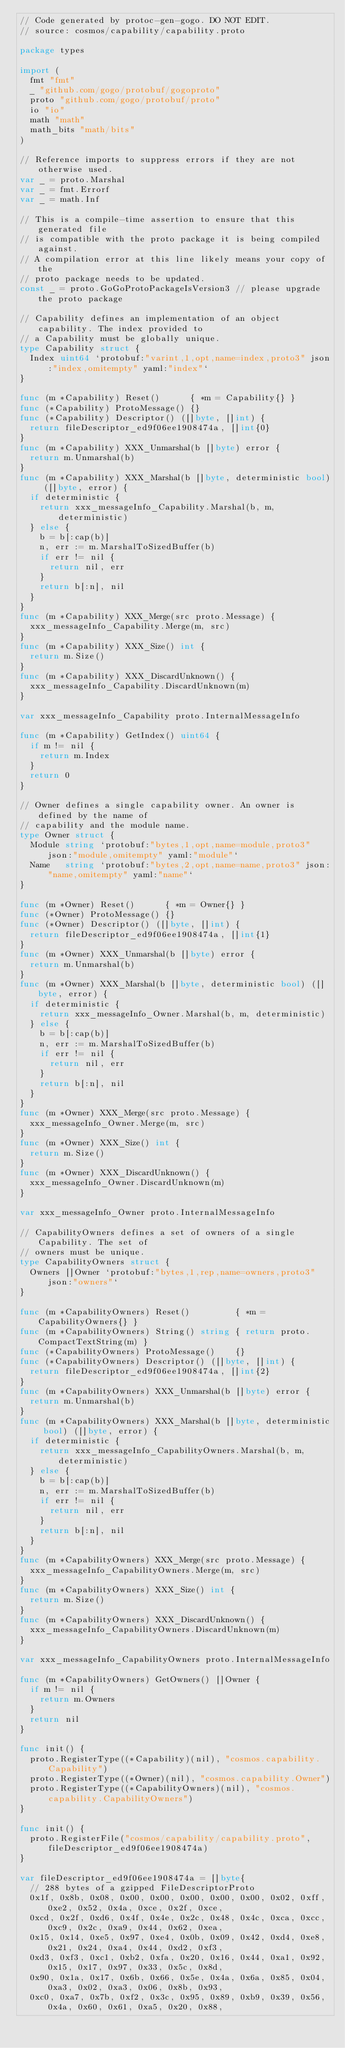<code> <loc_0><loc_0><loc_500><loc_500><_Go_>// Code generated by protoc-gen-gogo. DO NOT EDIT.
// source: cosmos/capability/capability.proto

package types

import (
	fmt "fmt"
	_ "github.com/gogo/protobuf/gogoproto"
	proto "github.com/gogo/protobuf/proto"
	io "io"
	math "math"
	math_bits "math/bits"
)

// Reference imports to suppress errors if they are not otherwise used.
var _ = proto.Marshal
var _ = fmt.Errorf
var _ = math.Inf

// This is a compile-time assertion to ensure that this generated file
// is compatible with the proto package it is being compiled against.
// A compilation error at this line likely means your copy of the
// proto package needs to be updated.
const _ = proto.GoGoProtoPackageIsVersion3 // please upgrade the proto package

// Capability defines an implementation of an object capability. The index provided to
// a Capability must be globally unique.
type Capability struct {
	Index uint64 `protobuf:"varint,1,opt,name=index,proto3" json:"index,omitempty" yaml:"index"`
}

func (m *Capability) Reset()      { *m = Capability{} }
func (*Capability) ProtoMessage() {}
func (*Capability) Descriptor() ([]byte, []int) {
	return fileDescriptor_ed9f06ee1908474a, []int{0}
}
func (m *Capability) XXX_Unmarshal(b []byte) error {
	return m.Unmarshal(b)
}
func (m *Capability) XXX_Marshal(b []byte, deterministic bool) ([]byte, error) {
	if deterministic {
		return xxx_messageInfo_Capability.Marshal(b, m, deterministic)
	} else {
		b = b[:cap(b)]
		n, err := m.MarshalToSizedBuffer(b)
		if err != nil {
			return nil, err
		}
		return b[:n], nil
	}
}
func (m *Capability) XXX_Merge(src proto.Message) {
	xxx_messageInfo_Capability.Merge(m, src)
}
func (m *Capability) XXX_Size() int {
	return m.Size()
}
func (m *Capability) XXX_DiscardUnknown() {
	xxx_messageInfo_Capability.DiscardUnknown(m)
}

var xxx_messageInfo_Capability proto.InternalMessageInfo

func (m *Capability) GetIndex() uint64 {
	if m != nil {
		return m.Index
	}
	return 0
}

// Owner defines a single capability owner. An owner is defined by the name of
// capability and the module name.
type Owner struct {
	Module string `protobuf:"bytes,1,opt,name=module,proto3" json:"module,omitempty" yaml:"module"`
	Name   string `protobuf:"bytes,2,opt,name=name,proto3" json:"name,omitempty" yaml:"name"`
}

func (m *Owner) Reset()      { *m = Owner{} }
func (*Owner) ProtoMessage() {}
func (*Owner) Descriptor() ([]byte, []int) {
	return fileDescriptor_ed9f06ee1908474a, []int{1}
}
func (m *Owner) XXX_Unmarshal(b []byte) error {
	return m.Unmarshal(b)
}
func (m *Owner) XXX_Marshal(b []byte, deterministic bool) ([]byte, error) {
	if deterministic {
		return xxx_messageInfo_Owner.Marshal(b, m, deterministic)
	} else {
		b = b[:cap(b)]
		n, err := m.MarshalToSizedBuffer(b)
		if err != nil {
			return nil, err
		}
		return b[:n], nil
	}
}
func (m *Owner) XXX_Merge(src proto.Message) {
	xxx_messageInfo_Owner.Merge(m, src)
}
func (m *Owner) XXX_Size() int {
	return m.Size()
}
func (m *Owner) XXX_DiscardUnknown() {
	xxx_messageInfo_Owner.DiscardUnknown(m)
}

var xxx_messageInfo_Owner proto.InternalMessageInfo

// CapabilityOwners defines a set of owners of a single Capability. The set of
// owners must be unique.
type CapabilityOwners struct {
	Owners []Owner `protobuf:"bytes,1,rep,name=owners,proto3" json:"owners"`
}

func (m *CapabilityOwners) Reset()         { *m = CapabilityOwners{} }
func (m *CapabilityOwners) String() string { return proto.CompactTextString(m) }
func (*CapabilityOwners) ProtoMessage()    {}
func (*CapabilityOwners) Descriptor() ([]byte, []int) {
	return fileDescriptor_ed9f06ee1908474a, []int{2}
}
func (m *CapabilityOwners) XXX_Unmarshal(b []byte) error {
	return m.Unmarshal(b)
}
func (m *CapabilityOwners) XXX_Marshal(b []byte, deterministic bool) ([]byte, error) {
	if deterministic {
		return xxx_messageInfo_CapabilityOwners.Marshal(b, m, deterministic)
	} else {
		b = b[:cap(b)]
		n, err := m.MarshalToSizedBuffer(b)
		if err != nil {
			return nil, err
		}
		return b[:n], nil
	}
}
func (m *CapabilityOwners) XXX_Merge(src proto.Message) {
	xxx_messageInfo_CapabilityOwners.Merge(m, src)
}
func (m *CapabilityOwners) XXX_Size() int {
	return m.Size()
}
func (m *CapabilityOwners) XXX_DiscardUnknown() {
	xxx_messageInfo_CapabilityOwners.DiscardUnknown(m)
}

var xxx_messageInfo_CapabilityOwners proto.InternalMessageInfo

func (m *CapabilityOwners) GetOwners() []Owner {
	if m != nil {
		return m.Owners
	}
	return nil
}

func init() {
	proto.RegisterType((*Capability)(nil), "cosmos.capability.Capability")
	proto.RegisterType((*Owner)(nil), "cosmos.capability.Owner")
	proto.RegisterType((*CapabilityOwners)(nil), "cosmos.capability.CapabilityOwners")
}

func init() {
	proto.RegisterFile("cosmos/capability/capability.proto", fileDescriptor_ed9f06ee1908474a)
}

var fileDescriptor_ed9f06ee1908474a = []byte{
	// 288 bytes of a gzipped FileDescriptorProto
	0x1f, 0x8b, 0x08, 0x00, 0x00, 0x00, 0x00, 0x00, 0x02, 0xff, 0xe2, 0x52, 0x4a, 0xce, 0x2f, 0xce,
	0xcd, 0x2f, 0xd6, 0x4f, 0x4e, 0x2c, 0x48, 0x4c, 0xca, 0xcc, 0xc9, 0x2c, 0xa9, 0x44, 0x62, 0xea,
	0x15, 0x14, 0xe5, 0x97, 0xe4, 0x0b, 0x09, 0x42, 0xd4, 0xe8, 0x21, 0x24, 0xa4, 0x44, 0xd2, 0xf3,
	0xd3, 0xf3, 0xc1, 0xb2, 0xfa, 0x20, 0x16, 0x44, 0xa1, 0x92, 0x15, 0x17, 0x97, 0x33, 0x5c, 0x8d,
	0x90, 0x1a, 0x17, 0x6b, 0x66, 0x5e, 0x4a, 0x6a, 0x85, 0x04, 0xa3, 0x02, 0xa3, 0x06, 0x8b, 0x93,
	0xc0, 0xa7, 0x7b, 0xf2, 0x3c, 0x95, 0x89, 0xb9, 0x39, 0x56, 0x4a, 0x60, 0x61, 0xa5, 0x20, 0x88,</code> 